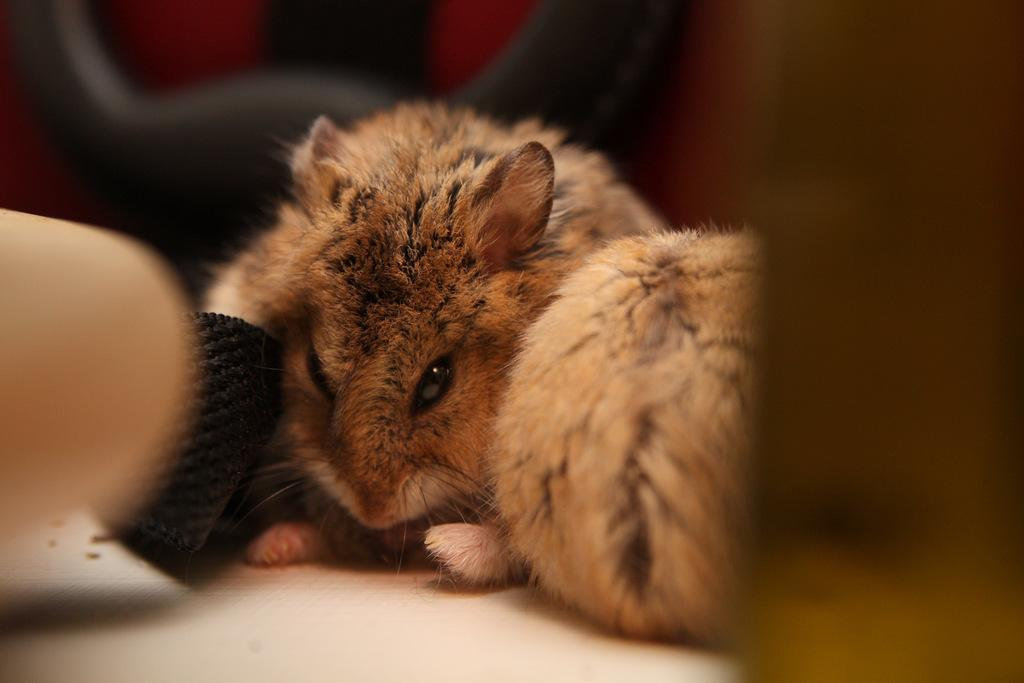What type of living organisms can be seen in the image? There are animals in the image. What colors are the animals? The animals are in brown and black colors. What color is the surface on which the animals are placed? The animals are on a white color surface. What colors can be seen in the background of the image? The background of the image is black and red in color. How is the background of the image depicted? The background is blurred. What month is depicted in the image? There is no month depicted in the image; it features animals on a white surface with a black and red blurred background. 